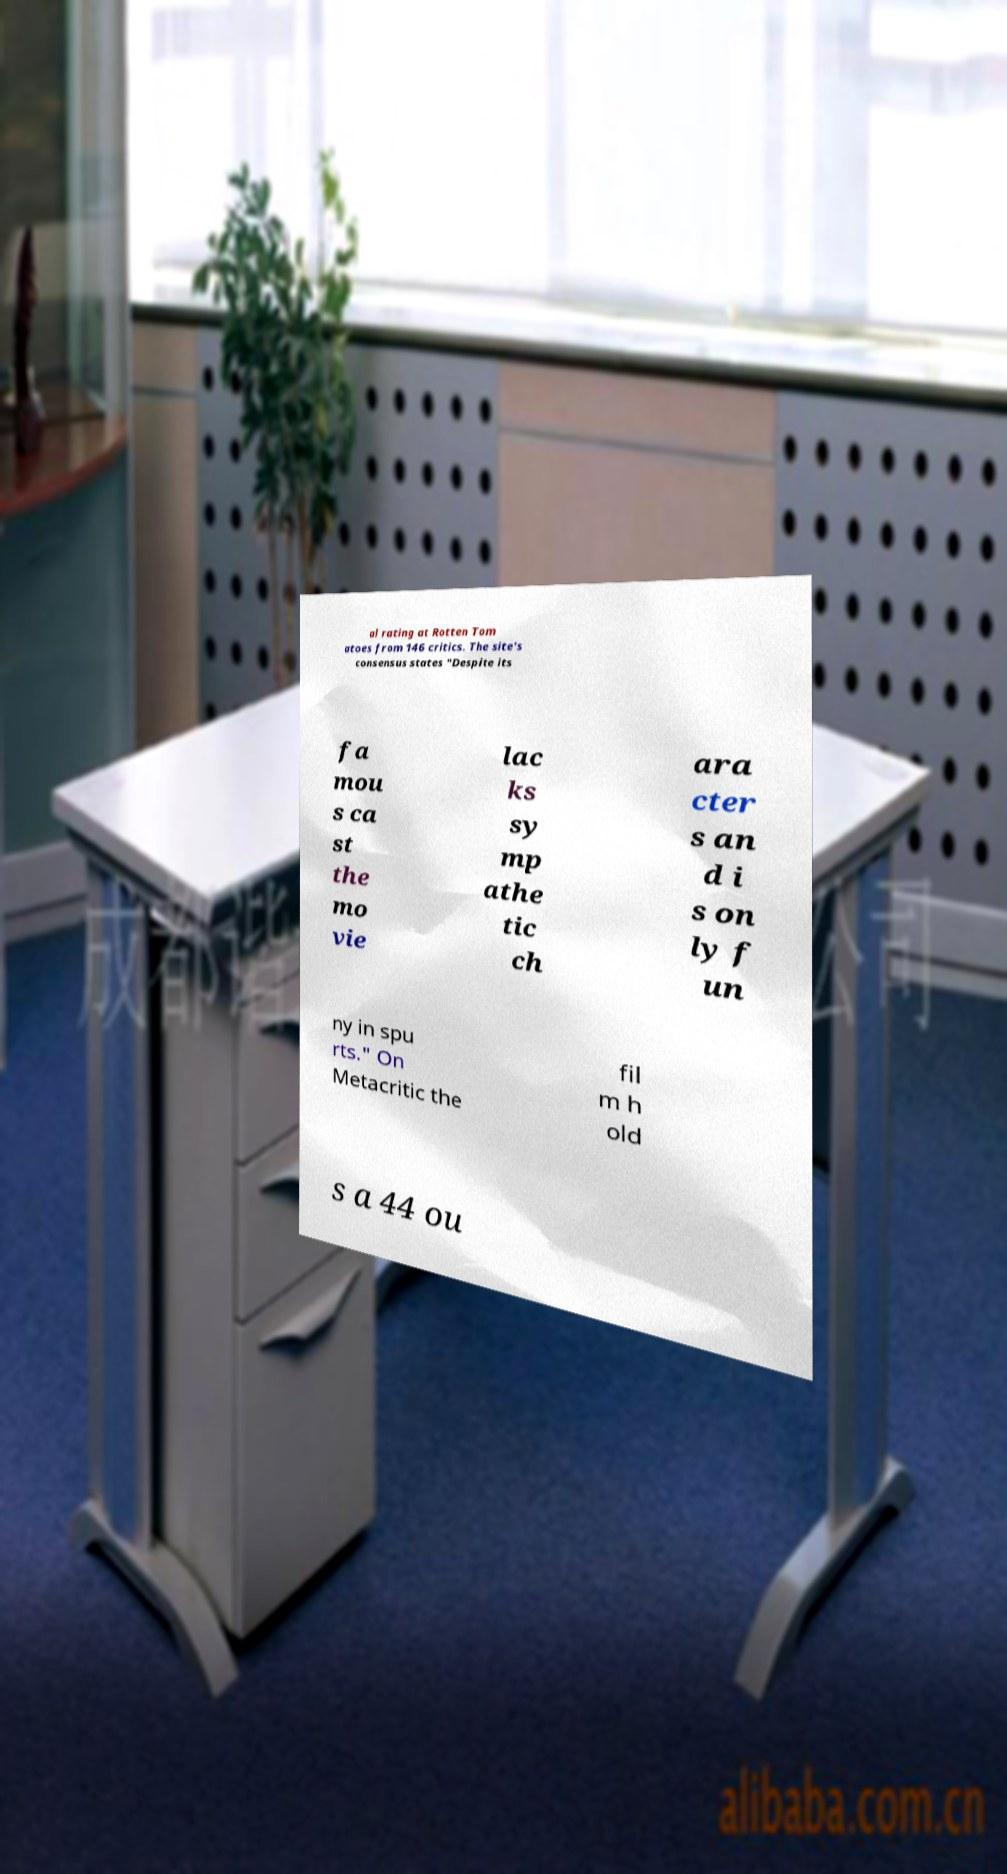Could you extract and type out the text from this image? al rating at Rotten Tom atoes from 146 critics. The site's consensus states "Despite its fa mou s ca st the mo vie lac ks sy mp athe tic ch ara cter s an d i s on ly f un ny in spu rts." On Metacritic the fil m h old s a 44 ou 